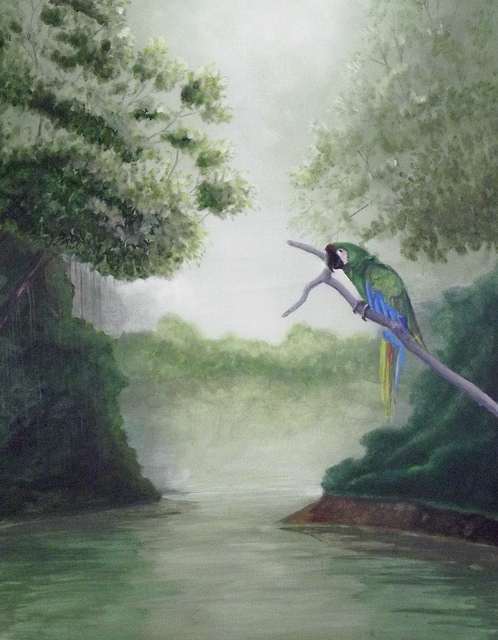<image>Is the artist of this painting famous? I don't know if the artist of this painting is famous. Is the artist of this painting famous? I don't know if the artist of this painting is famous. It can be both famous or not famous. 